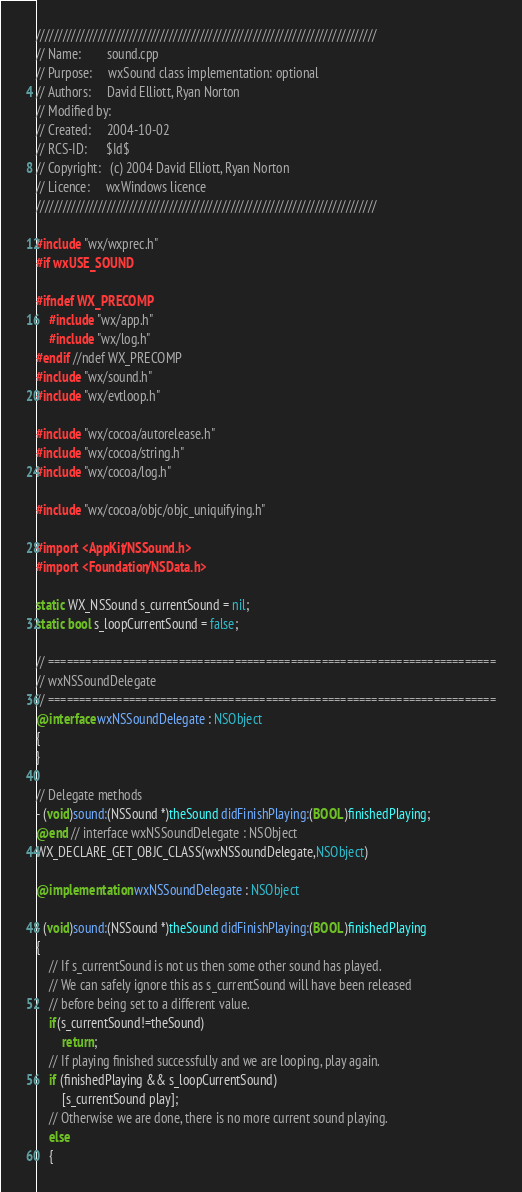<code> <loc_0><loc_0><loc_500><loc_500><_ObjectiveC_>/////////////////////////////////////////////////////////////////////////////
// Name:        sound.cpp
// Purpose:     wxSound class implementation: optional
// Authors:     David Elliott, Ryan Norton
// Modified by: 
// Created:     2004-10-02
// RCS-ID:      $Id$
// Copyright:   (c) 2004 David Elliott, Ryan Norton
// Licence:     wxWindows licence
/////////////////////////////////////////////////////////////////////////////

#include "wx/wxprec.h"
#if wxUSE_SOUND

#ifndef WX_PRECOMP
    #include "wx/app.h"
    #include "wx/log.h"
#endif //ndef WX_PRECOMP
#include "wx/sound.h"
#include "wx/evtloop.h"

#include "wx/cocoa/autorelease.h"
#include "wx/cocoa/string.h"
#include "wx/cocoa/log.h"

#include "wx/cocoa/objc/objc_uniquifying.h"

#import <AppKit/NSSound.h>
#import <Foundation/NSData.h>

static WX_NSSound s_currentSound = nil;
static bool s_loopCurrentSound = false;

// ========================================================================
// wxNSSoundDelegate
// ========================================================================
@interface wxNSSoundDelegate : NSObject
{
}

// Delegate methods
- (void)sound:(NSSound *)theSound didFinishPlaying:(BOOL)finishedPlaying;
@end // interface wxNSSoundDelegate : NSObject
WX_DECLARE_GET_OBJC_CLASS(wxNSSoundDelegate,NSObject)

@implementation wxNSSoundDelegate : NSObject

- (void)sound:(NSSound *)theSound didFinishPlaying:(BOOL)finishedPlaying
{
    // If s_currentSound is not us then some other sound has played.
    // We can safely ignore this as s_currentSound will have been released
    // before being set to a different value.
    if(s_currentSound!=theSound)
        return;
    // If playing finished successfully and we are looping, play again.
    if (finishedPlaying && s_loopCurrentSound)
        [s_currentSound play];
    // Otherwise we are done, there is no more current sound playing.
    else
    {</code> 